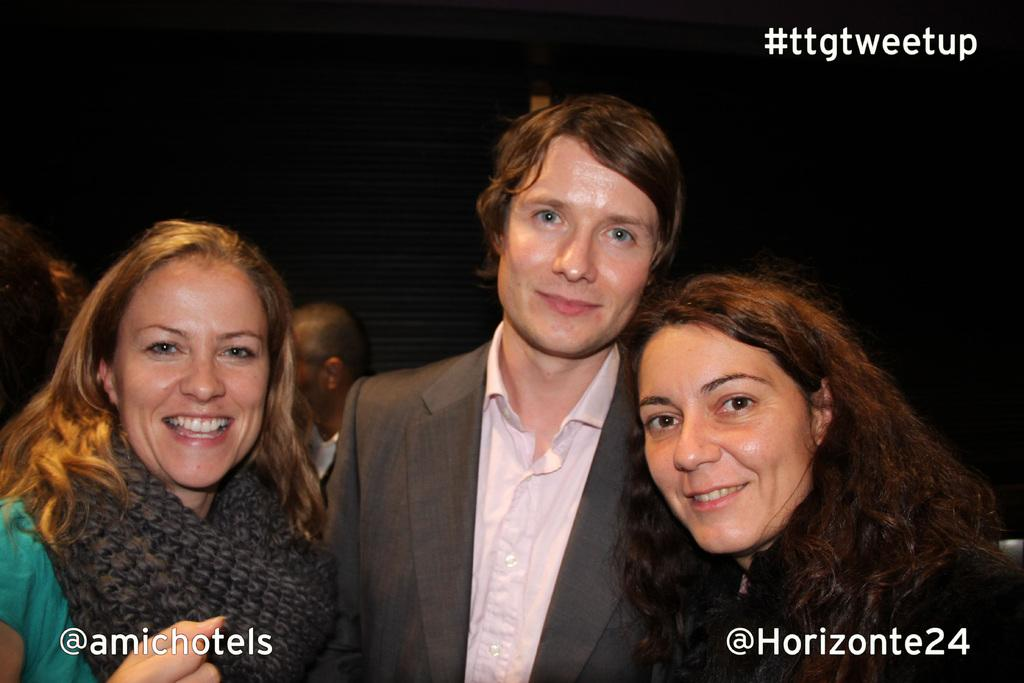How many people are in the image? There are three persons in the image. What are the persons in the image doing? The persons are watching and smiling. Can you describe the background of the image? There are people in the background of the image, and there is a black color object. The background view is dark. Reasoning: Let'g: Let's think step by step in order to produce the conversation. We start by identifying the number of people in the image, which is three. Then, we describe their actions, which are watching and smiling. Next, we focus on the background, mentioning the presence of people, a black color object, and the overall dark view. Absurd Question/Answer: What type of grain is being harvested by the house in the image? There is no house or grain present in the image. Can you tell me how many cords are connected to the black object in the background? There is no mention of cords connected to the black object in the image. 